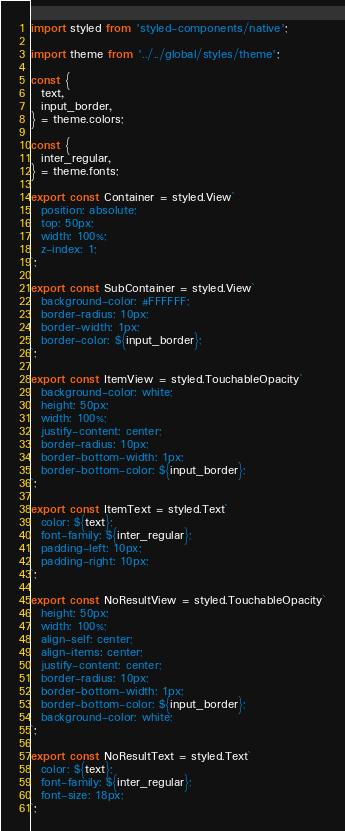<code> <loc_0><loc_0><loc_500><loc_500><_TypeScript_>import styled from 'styled-components/native';

import theme from '../../global/styles/theme';

const {
  text,
  input_border,
} = theme.colors;

const {
  inter_regular,
} = theme.fonts;

export const Container = styled.View`
  position: absolute;
  top: 50px;
  width: 100%;
  z-index: 1;
`;

export const SubContainer = styled.View`
  background-color: #FFFFFF;
  border-radius: 10px;
  border-width: 1px;
  border-color: ${input_border};
`;

export const ItemView = styled.TouchableOpacity`
  background-color: white;
  height: 50px;
  width: 100%;
  justify-content: center;
  border-radius: 10px;
  border-bottom-width: 1px;
  border-bottom-color: ${input_border};
`;

export const ItemText = styled.Text`
  color: ${text};
  font-family: ${inter_regular};
  padding-left: 10px;
  padding-right: 10px;
`;

export const NoResultView = styled.TouchableOpacity`
  height: 50px;
  width: 100%;
  align-self: center;
  align-items: center;
  justify-content: center;
  border-radius: 10px;
  border-bottom-width: 1px;
  border-bottom-color: ${input_border};
  background-color: white;
`;

export const NoResultText = styled.Text`
  color: ${text};
  font-family: ${inter_regular};
  font-size: 18px;
`;
</code> 